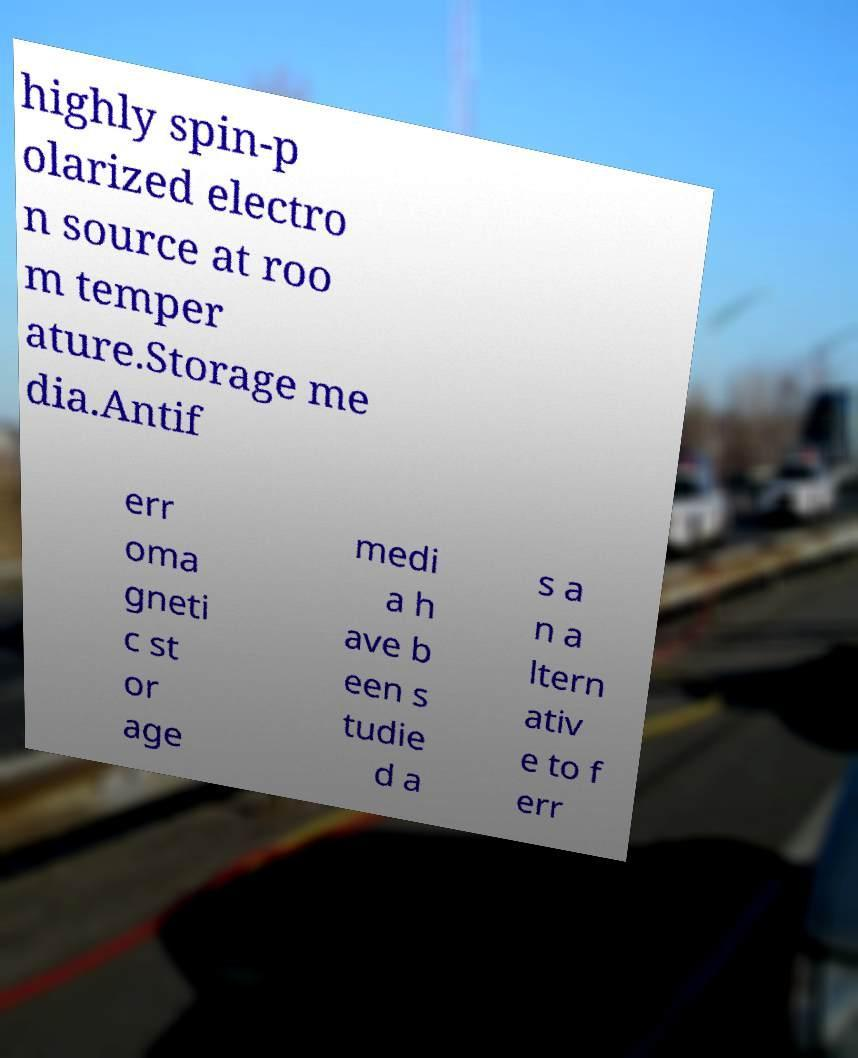Please read and relay the text visible in this image. What does it say? highly spin-p olarized electro n source at roo m temper ature.Storage me dia.Antif err oma gneti c st or age medi a h ave b een s tudie d a s a n a ltern ativ e to f err 